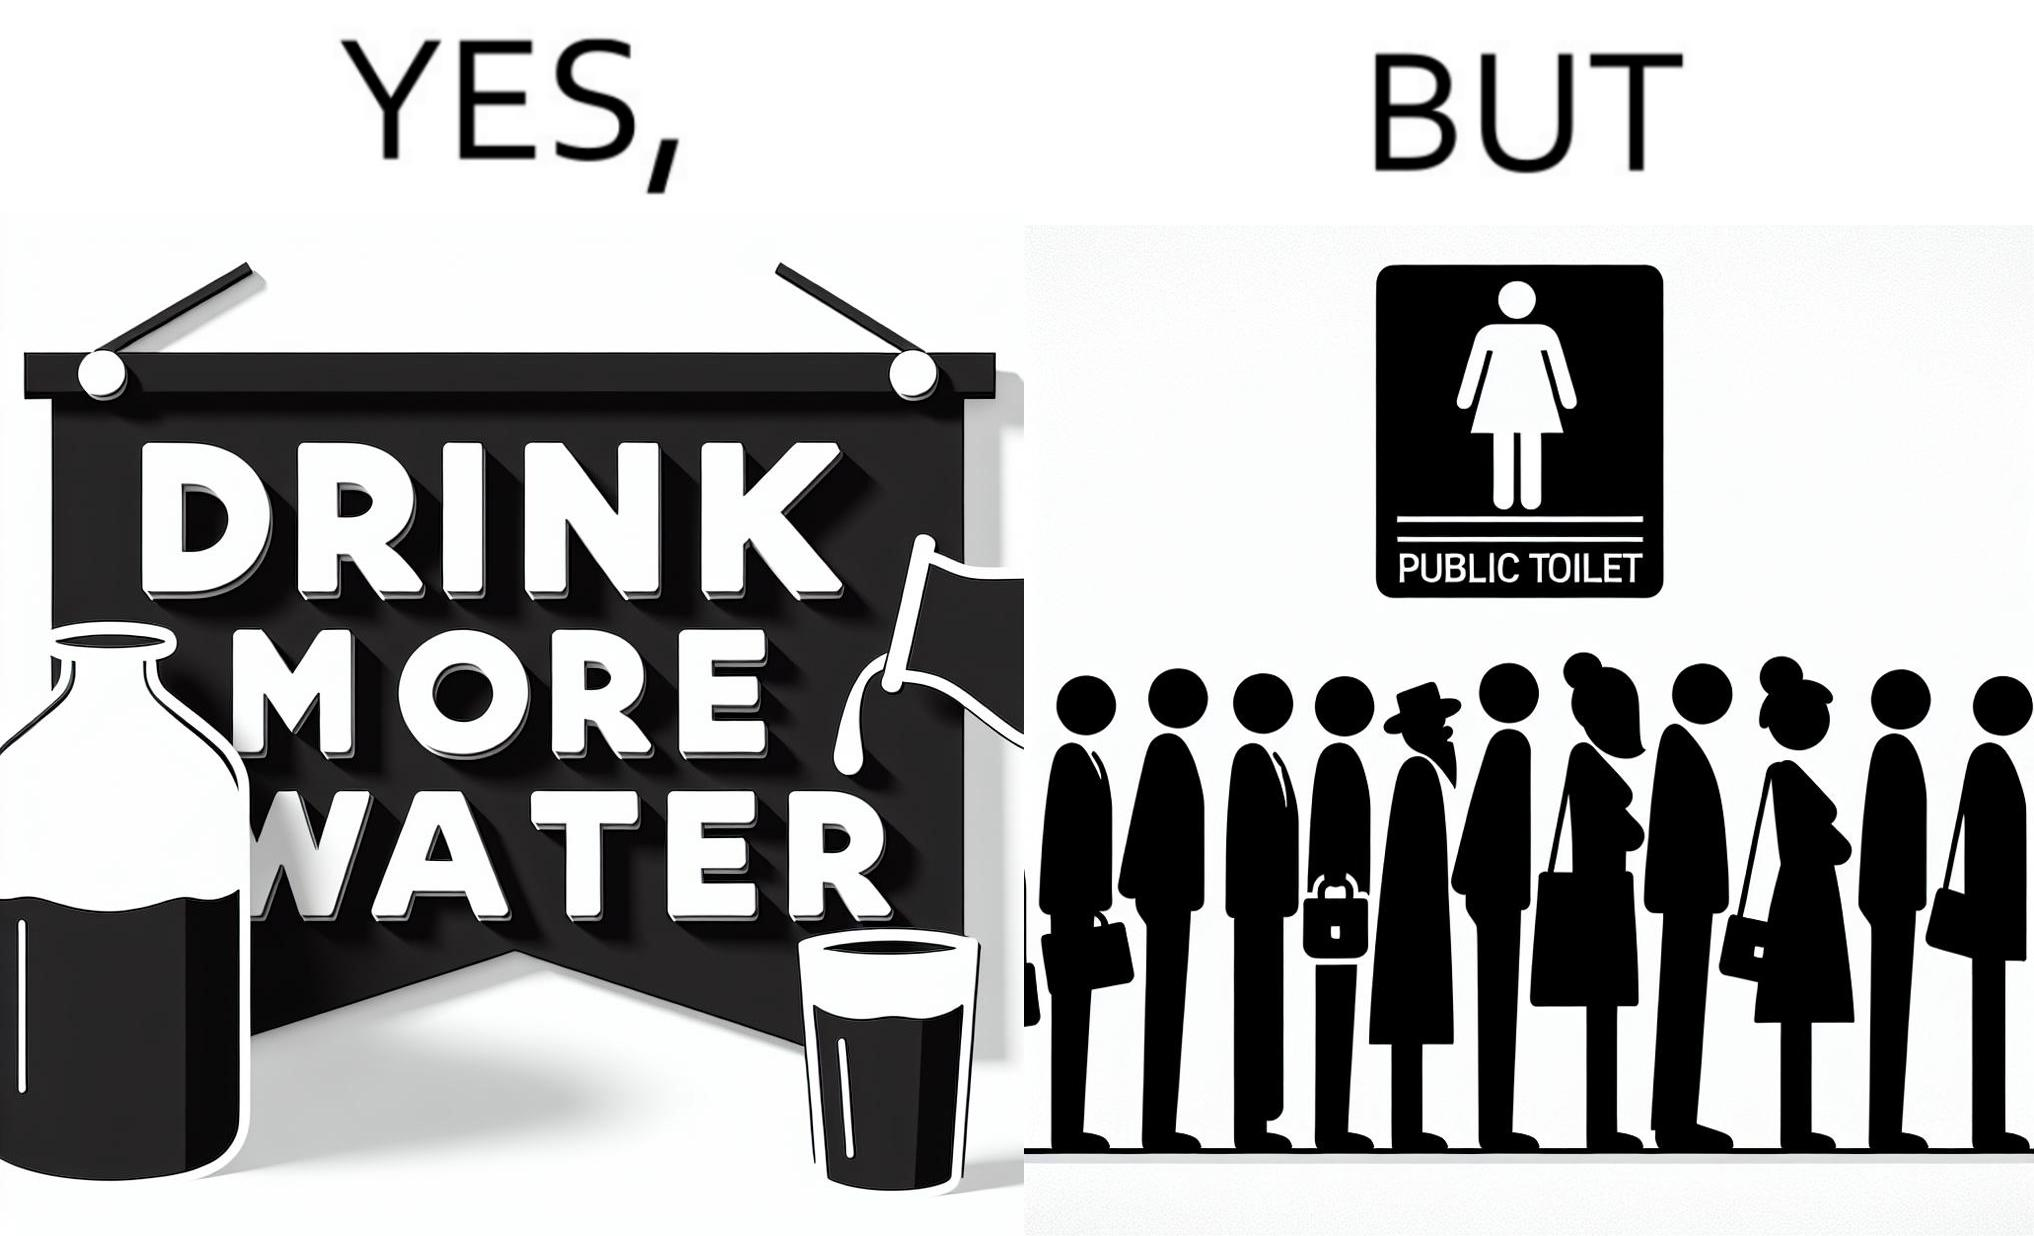Does this image contain satire or humor? Yes, this image is satirical. 